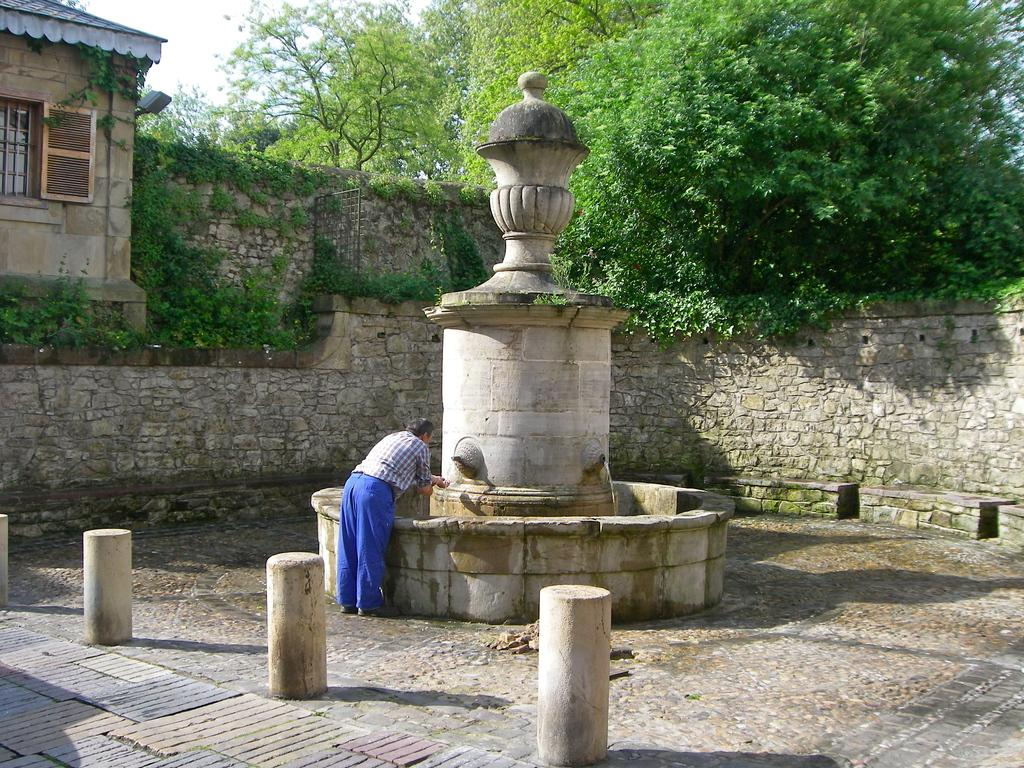What is the man in the image doing? The man is standing on the ground in the image. What can be seen in the image besides the man? There is water, poles, plants, trees, a house, a wall, and the sky visible in the image. Can you describe the natural elements in the image? There are plants and trees in the image. What type of structure is present in the image? There is a house in the image. What is the background of the image? The sky is visible in the background of the image. What type of horn is being played by the man in the image? There is no horn present in the image; the man is simply standing on the ground. What month is it in the image? The month cannot be determined from the image, as it does not contain any information about the time of year. 